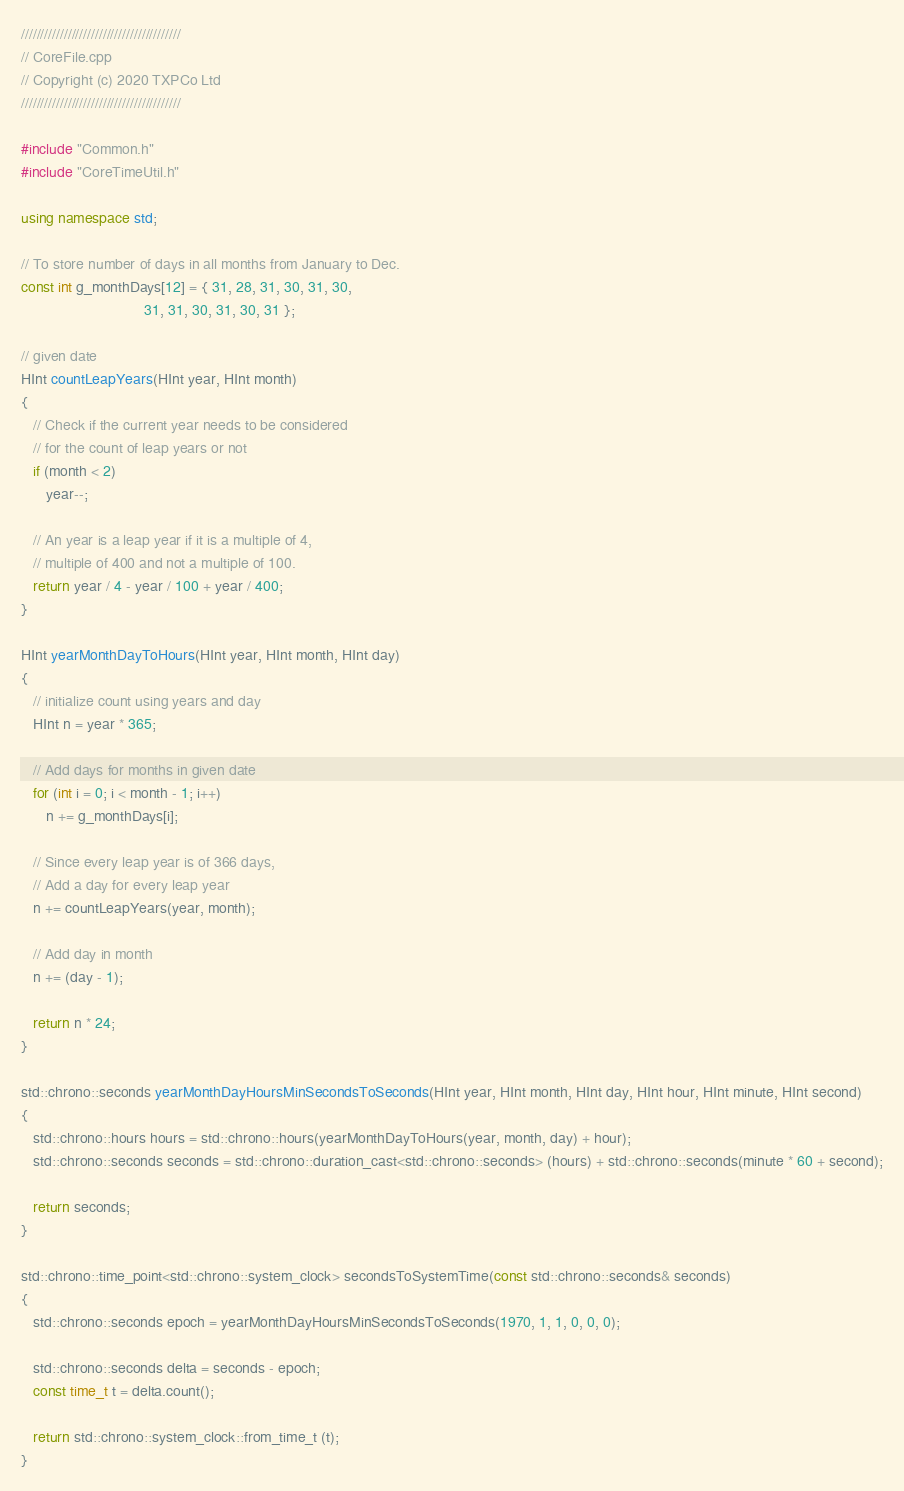<code> <loc_0><loc_0><loc_500><loc_500><_C++_>/////////////////////////////////////////
// CoreFile.cpp
// Copyright (c) 2020 TXPCo Ltd
/////////////////////////////////////////

#include "Common.h"
#include "CoreTimeUtil.h"

using namespace std;

// To store number of days in all months from January to Dec. 
const int g_monthDays[12] = { 31, 28, 31, 30, 31, 30,
                              31, 31, 30, 31, 30, 31 };

// given date 
HInt countLeapYears(HInt year, HInt month)
{
   // Check if the current year needs to be considered 
   // for the count of leap years or not 
   if (month < 2)
      year--;

   // An year is a leap year if it is a multiple of 4, 
   // multiple of 400 and not a multiple of 100. 
   return year / 4 - year / 100 + year / 400;
}

HInt yearMonthDayToHours(HInt year, HInt month, HInt day)
{
   // initialize count using years and day 
   HInt n = year * 365;

   // Add days for months in given date 
   for (int i = 0; i < month - 1; i++)
      n += g_monthDays[i];

   // Since every leap year is of 366 days, 
   // Add a day for every leap year 
   n += countLeapYears(year, month);

   // Add day in month
   n += (day - 1);

   return n * 24;
}

std::chrono::seconds yearMonthDayHoursMinSecondsToSeconds(HInt year, HInt month, HInt day, HInt hour, HInt minute, HInt second)
{
   std::chrono::hours hours = std::chrono::hours(yearMonthDayToHours(year, month, day) + hour);
   std::chrono::seconds seconds = std::chrono::duration_cast<std::chrono::seconds> (hours) + std::chrono::seconds(minute * 60 + second);

   return seconds;
}

std::chrono::time_point<std::chrono::system_clock> secondsToSystemTime(const std::chrono::seconds& seconds)
{
   std::chrono::seconds epoch = yearMonthDayHoursMinSecondsToSeconds(1970, 1, 1, 0, 0, 0);

   std::chrono::seconds delta = seconds - epoch;
   const time_t t = delta.count();

   return std::chrono::system_clock::from_time_t (t);
}</code> 